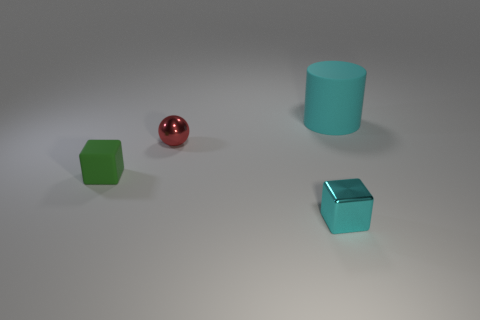What is the source of light in this scene? In the image, the source of light is not directly visible, but based on the shadows and highlights on the objects, the light seems to be coming from above, slightly towards the front of the objects. The soft shadows indicate that the light might be diffused, possibly coming from an overhead light source. 